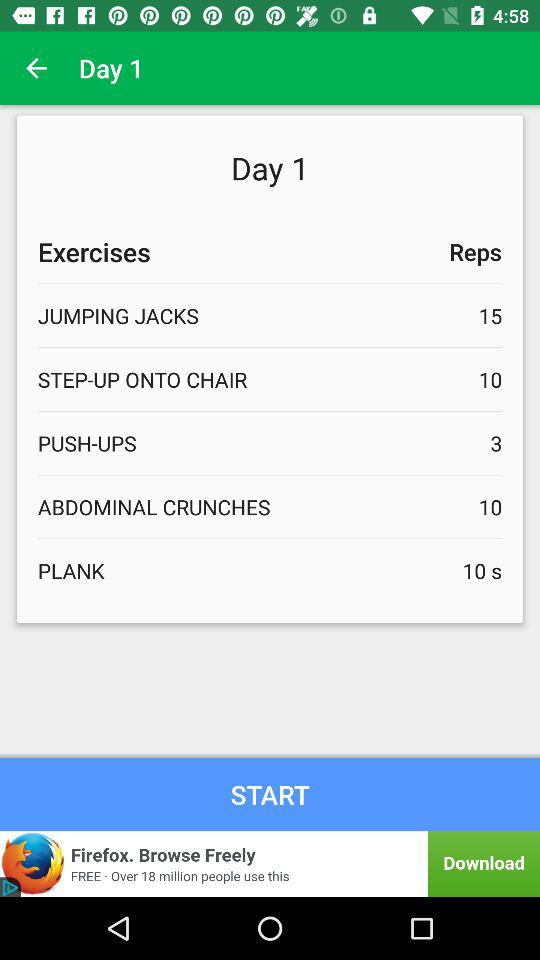How many reps for push-ups for day 1? There are 3 reps for push-ups for day 1. 